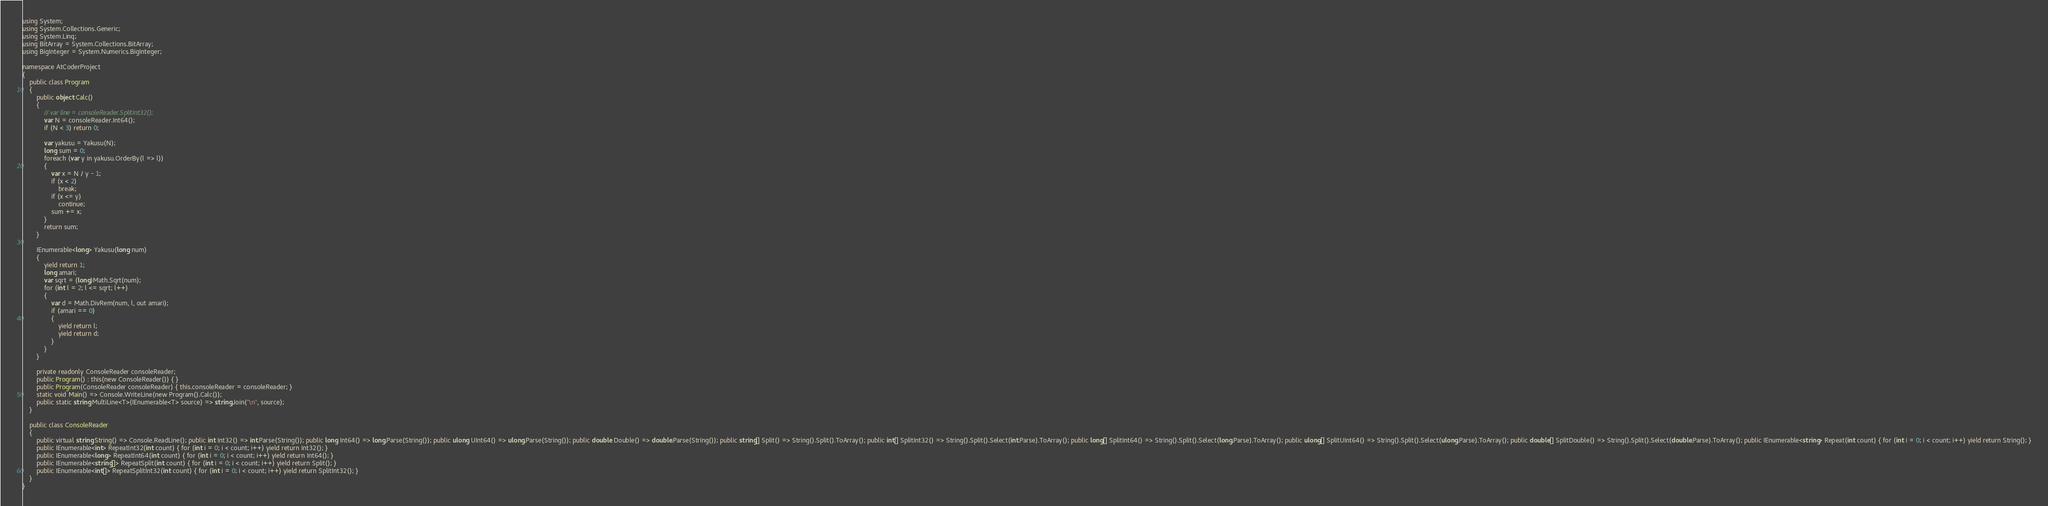Convert code to text. <code><loc_0><loc_0><loc_500><loc_500><_C#_>using System;
using System.Collections.Generic;
using System.Linq;
using BitArray = System.Collections.BitArray;
using BigInteger = System.Numerics.BigInteger;

namespace AtCoderProject
{
    public class Program
    {
        public object Calc()
        {
            // var line = consoleReader.SplitInt32();
            var N = consoleReader.Int64();
            if (N < 3) return 0;

            var yakusu = Yakusu(N);
            long sum = 0;
            foreach (var y in yakusu.OrderBy(l => l))
            {
                var x = N / y - 1;
                if (x < 2)
                    break;
                if (x <= y)
                    continue;
                sum += x;
            }
            return sum;
        }

        IEnumerable<long> Yakusu(long num)
        {
            yield return 1;
            long amari;
            var sqrt = (long)Math.Sqrt(num);
            for (int l = 2; l <= sqrt; l++)
            {
                var d = Math.DivRem(num, l, out amari);
                if (amari == 0)
                {
                    yield return l;
                    yield return d;
                }
            }
        }

        private readonly ConsoleReader consoleReader;
        public Program() : this(new ConsoleReader()) { }
        public Program(ConsoleReader consoleReader) { this.consoleReader = consoleReader; }
        static void Main() => Console.WriteLine(new Program().Calc());
        public static string MultiLine<T>(IEnumerable<T> source) => string.Join("\n", source);
    }

    public class ConsoleReader
    {
        public virtual string String() => Console.ReadLine(); public int Int32() => int.Parse(String()); public long Int64() => long.Parse(String()); public ulong UInt64() => ulong.Parse(String()); public double Double() => double.Parse(String()); public string[] Split() => String().Split().ToArray(); public int[] SplitInt32() => String().Split().Select(int.Parse).ToArray(); public long[] SplitInt64() => String().Split().Select(long.Parse).ToArray(); public ulong[] SplitUInt64() => String().Split().Select(ulong.Parse).ToArray(); public double[] SplitDouble() => String().Split().Select(double.Parse).ToArray(); public IEnumerable<string> Repeat(int count) { for (int i = 0; i < count; i++) yield return String(); }
        public IEnumerable<int> RepeatInt32(int count) { for (int i = 0; i < count; i++) yield return Int32(); }
        public IEnumerable<long> RepeatInt64(int count) { for (int i = 0; i < count; i++) yield return Int64(); }
        public IEnumerable<string[]> RepeatSplit(int count) { for (int i = 0; i < count; i++) yield return Split(); }
        public IEnumerable<int[]> RepeatSplitInt32(int count) { for (int i = 0; i < count; i++) yield return SplitInt32(); }
    }
}
</code> 